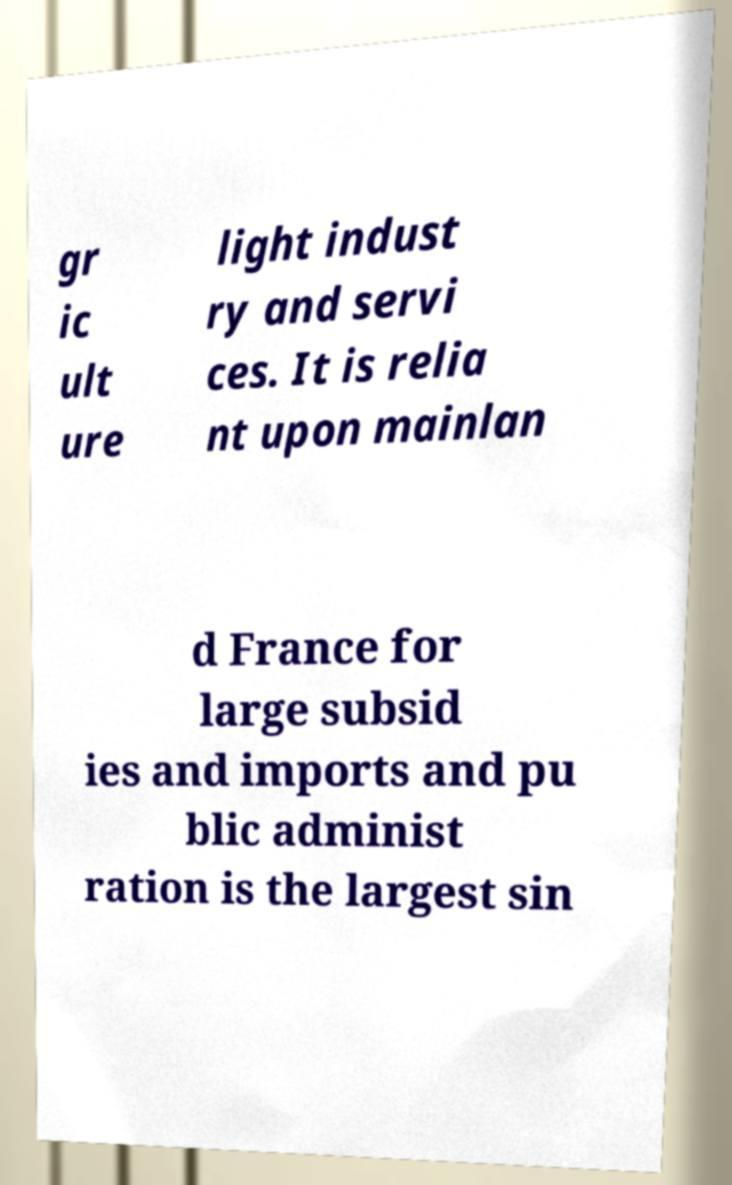Could you extract and type out the text from this image? gr ic ult ure light indust ry and servi ces. It is relia nt upon mainlan d France for large subsid ies and imports and pu blic administ ration is the largest sin 